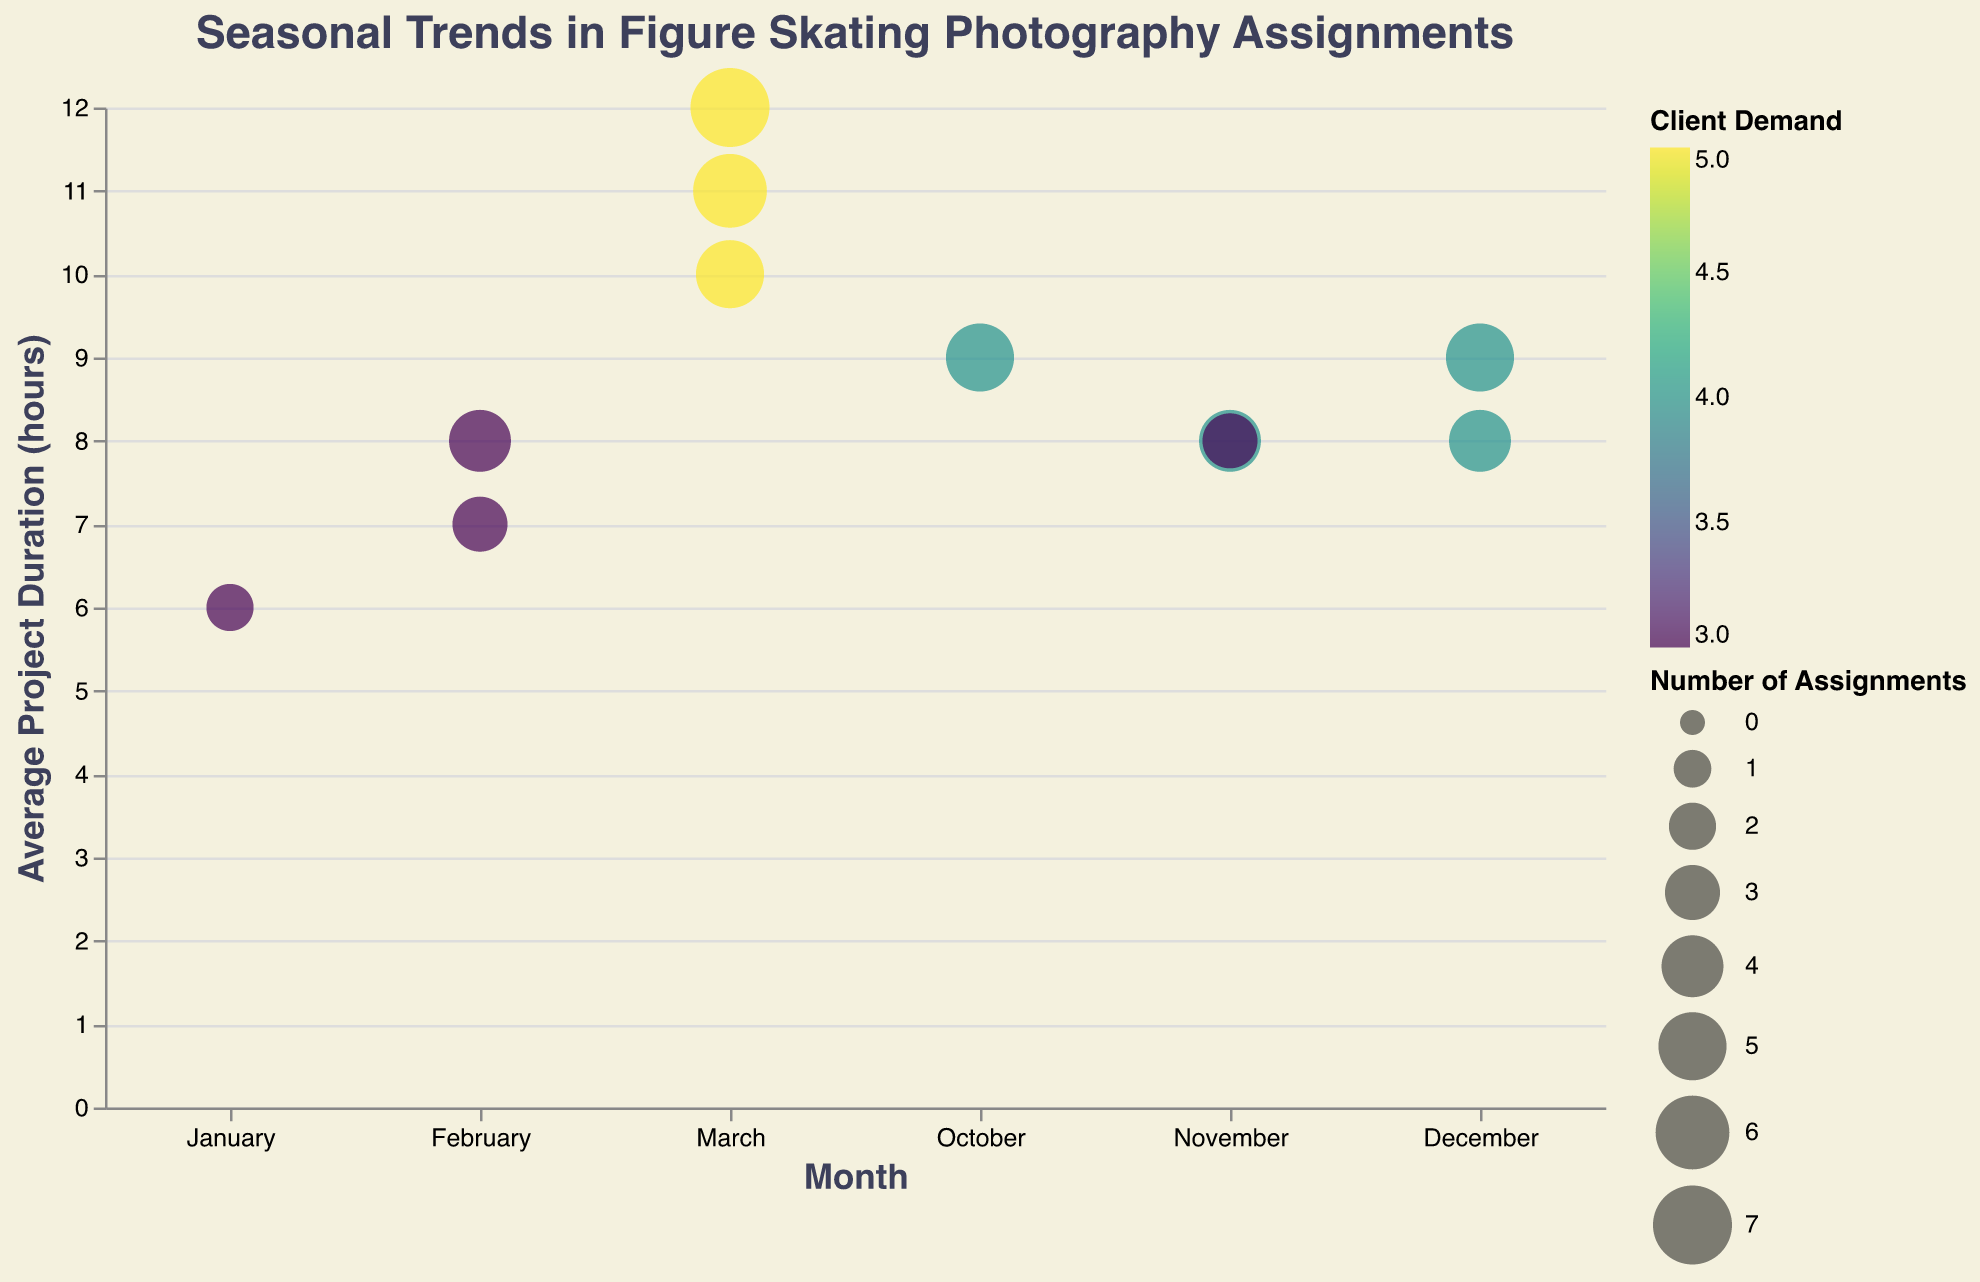What event had the highest number of assignments in 2023? Look at 2023 and check the size of the bubbles. The "World Figure Skating Championships" in March has the largest bubble.
Answer: World Figure Skating Championships Which month had the highest average project duration in 2022? Refer to the vertical axis and locate the highest bubble in 2022. The "World Figure Skating Championships" in March has the highest average project duration.
Answer: March How many assignments were conducted in November 2022? Look at the bubbles for November 2022 and note their sizes. "Skate America" had 4 assignments, and "Rostelecom Cup" had 3 assignments. The total is 4 + 3 = 7
Answer: 7 What's the trend in client demand for the "World Figure Skating Championships" from 2021 to 2023? Observe the color of bubbles for "World Figure Skating Championships" from 2021 to 2023. All are the same, with a client demand of 5.
Answer: Consistently high (5) Compare the average project duration between the "ISU Grand Prix Final" and the "Four Continents Championships" for 2023. Which one is higher? Compare the vertical positions of the bubbles for these two events in 2023. "ISU Grand Prix Final" has 9 hours while "Four Continents Championships" has 8 hours.
Answer: ISU Grand Prix Final What is the average number of assignments per event in 2021? Sum the number of assignments for all events in 2021 and divide by the number of events. (5+4+3+2)/4 = 3.5
Answer: 3.5 Which event had the lowest client demand in 2021? Look for the darkest-colored bubble in 2021, indicating lower client demand. The "Four Continents Championships" and "European Figure Skating Championships" have a demand of 3, which is the lowest.
Answer: Four Continents Championships and European Figure Skating Championships In which month do figure skating events occur most frequently across all years? Count the number of bubbles per month. March has a bubble every year and the highest number overall.
Answer: March What is the difference in the number of assignments between the "World Figure Skating Championships" in 2021 and 2023? Subtract the number of assignments in 2021 (5) from the number in 2023 (7). 7 - 5 = 2
Answer: 2 How does the number of assignments in December 2021 compare to December 2023? Compare the sizes of the bubbles in December 2021 and 2023. 2021 has 4 assignments and 2023 has 5.
Answer: December 2023 has more assignments 